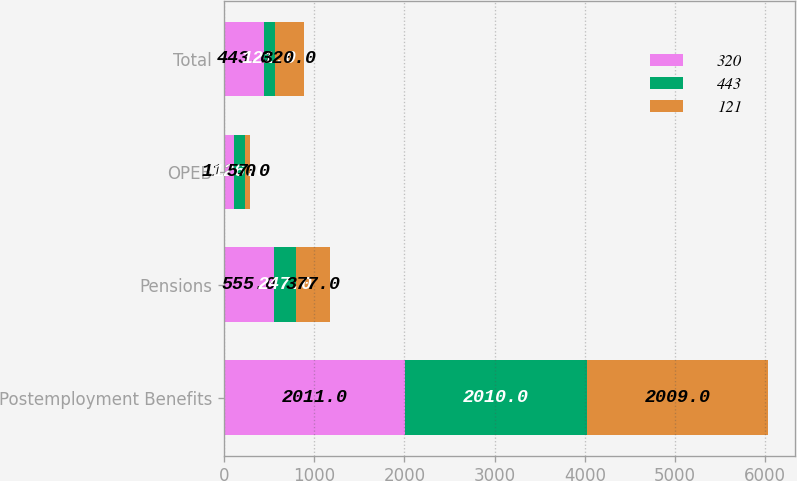<chart> <loc_0><loc_0><loc_500><loc_500><stacked_bar_chart><ecel><fcel>Postemployment Benefits<fcel>Pensions<fcel>OPEB<fcel>Total<nl><fcel>320<fcel>2011<fcel>555<fcel>112<fcel>443<nl><fcel>443<fcel>2010<fcel>247<fcel>126<fcel>121<nl><fcel>121<fcel>2009<fcel>377<fcel>57<fcel>320<nl></chart> 